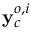Convert formula to latex. <formula><loc_0><loc_0><loc_500><loc_500>y _ { c } ^ { o , i }</formula> 